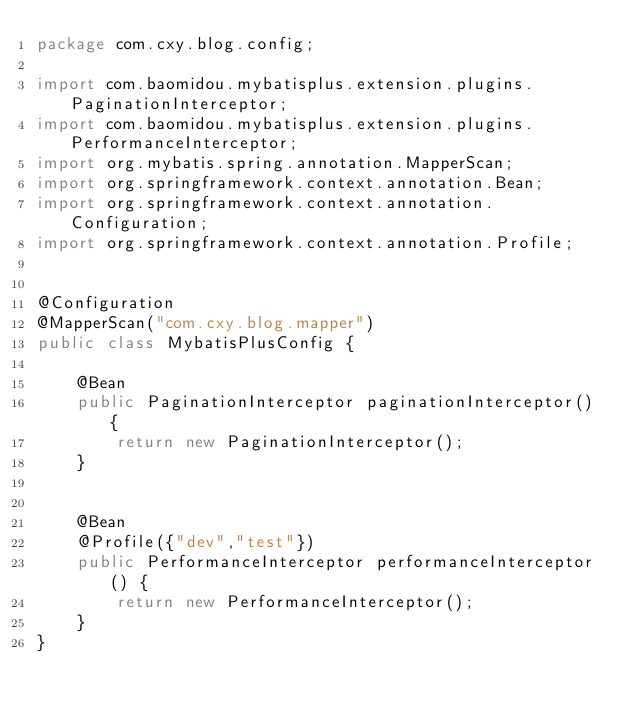<code> <loc_0><loc_0><loc_500><loc_500><_Java_>package com.cxy.blog.config;

import com.baomidou.mybatisplus.extension.plugins.PaginationInterceptor;
import com.baomidou.mybatisplus.extension.plugins.PerformanceInterceptor;
import org.mybatis.spring.annotation.MapperScan;
import org.springframework.context.annotation.Bean;
import org.springframework.context.annotation.Configuration;
import org.springframework.context.annotation.Profile;

 
@Configuration
@MapperScan("com.cxy.blog.mapper")
public class MybatisPlusConfig {
     
    @Bean
    public PaginationInterceptor paginationInterceptor() {
        return new PaginationInterceptor();
    }

     
    @Bean
    @Profile({"dev","test"})
    public PerformanceInterceptor performanceInterceptor() {
        return new PerformanceInterceptor();
    }
}
</code> 